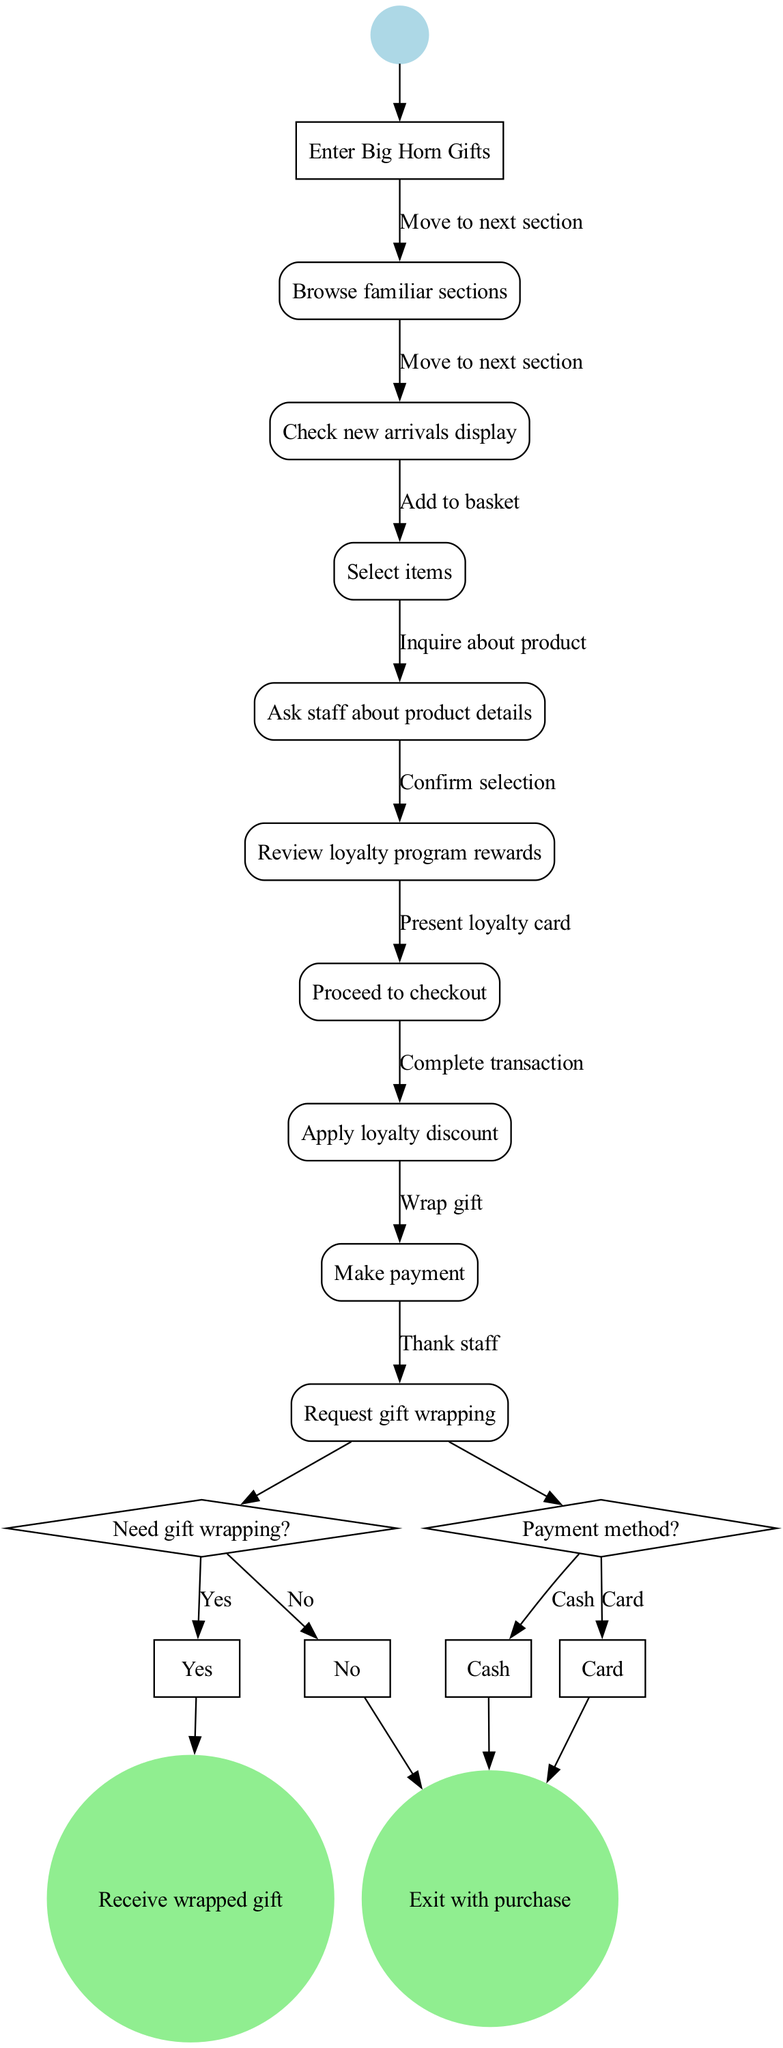What is the first activity in the shopping process? The initial node indicates the starting point of the process, which is "Enter Big Horn Gifts."
Answer: Enter Big Horn Gifts How many activities are there in total? By counting the nodes labeled as activities in the diagram, there are 8 activities defined in the 'activities' list.
Answer: 8 What is the last activity before the decision on gift wrapping? The last activity before the decision is "Review loyalty program rewards," which comes immediately before the decision node.
Answer: Review loyalty program rewards What happens if the payment method is selected as cash? The edges show that if the payment method is "Cash," it leads to the final node "Exit with purchase," indicating the transaction completes successfully.
Answer: Exit with purchase Is there an inquiry about product details in the shopping process? The edge labeled "Inquire about product" connects the activity "Ask staff about product details," confirming that there is an inquiry present in the process.
Answer: Yes What do the final nodes signify? The final nodes represent the outcomes of the shopping process, either receiving a wrapped gift or exiting with a purchase, indicating the end of the flow.
Answer: Receive wrapped gift, Exit with purchase What is the relationship between "Select items" and "Proceed to checkout"? The edge labeled "Add to basket" connects "Select items" to "Proceed to checkout," showing that selecting items leads logically to checkout.
Answer: Add to basket What follows after applying the loyalty discount? The next step after "Apply loyalty discount" is making the payment, which is shown as an edge leading to the "Make payment" activity.
Answer: Make payment What question is posed to customers regarding gift wrapping? The decision node presents the question "Need gift wrapping?" which requires a binary yes or no response from the customer.
Answer: Need gift wrapping? 